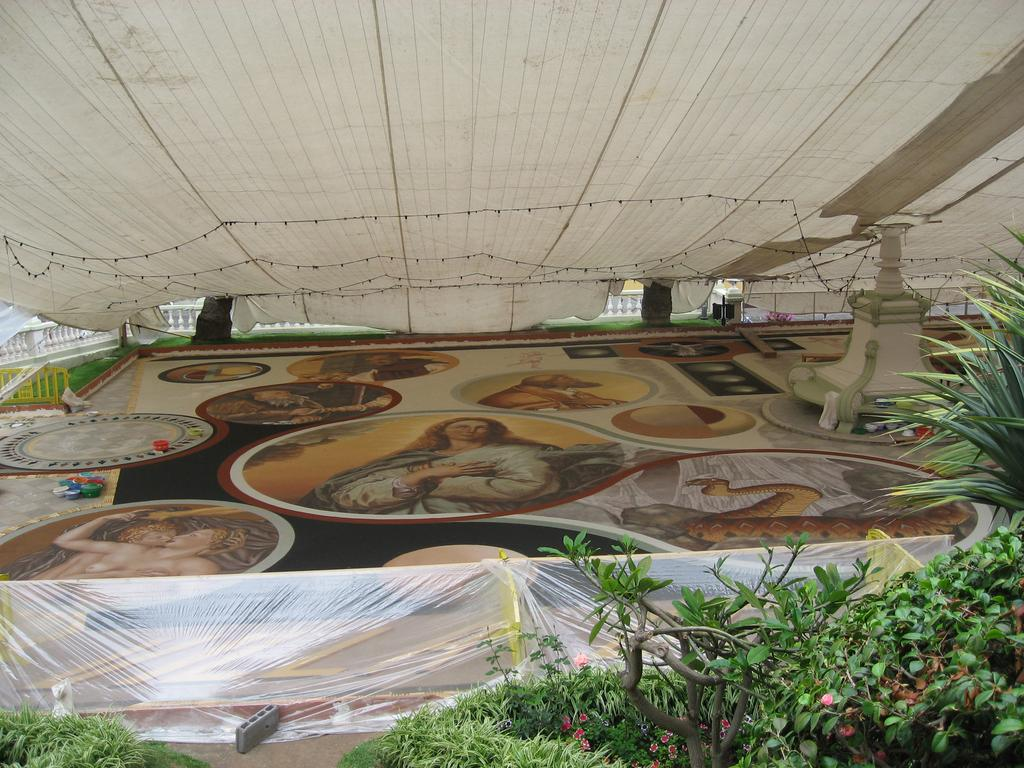What type of living organisms can be seen in the image? Plants can be seen in the image. What is located behind the plants? There is a board behind the plants. What is on the board? There is a painting on the board. What is at the top of the board? There is a white cloth at the top of the board. What type of wax can be seen dripping from the arm in the image? There is no arm or wax present in the image. 